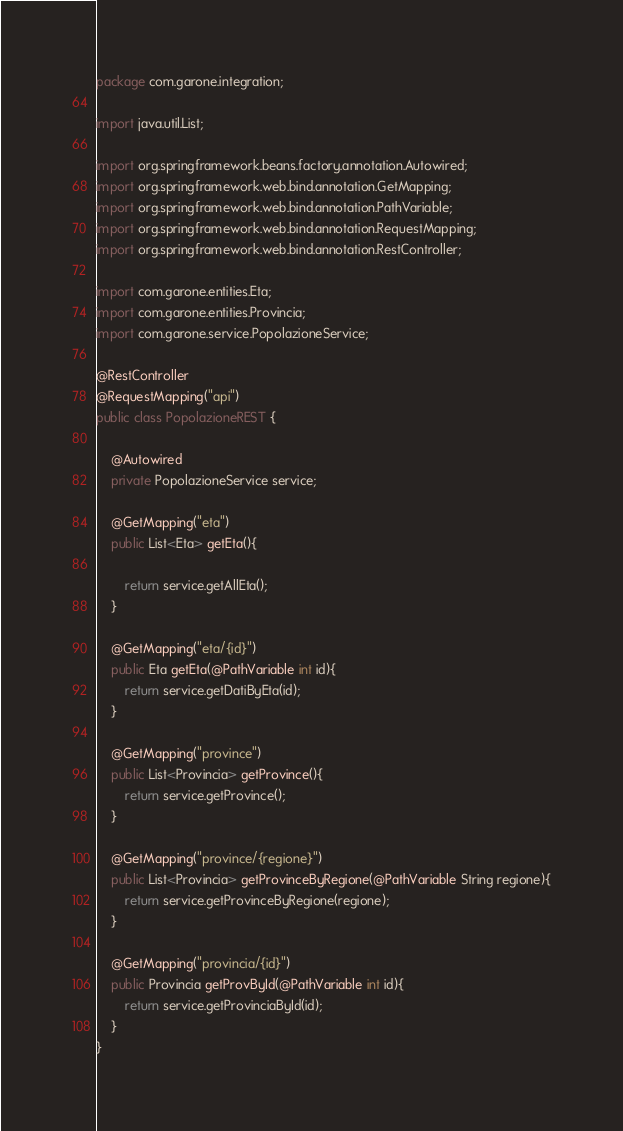<code> <loc_0><loc_0><loc_500><loc_500><_Java_>package com.garone.integration;

import java.util.List;

import org.springframework.beans.factory.annotation.Autowired;
import org.springframework.web.bind.annotation.GetMapping;
import org.springframework.web.bind.annotation.PathVariable;
import org.springframework.web.bind.annotation.RequestMapping;
import org.springframework.web.bind.annotation.RestController;

import com.garone.entities.Eta;
import com.garone.entities.Provincia;
import com.garone.service.PopolazioneService;

@RestController
@RequestMapping("api")
public class PopolazioneREST {

	@Autowired
	private PopolazioneService service;
	
	@GetMapping("eta")
	public List<Eta> getEta(){
		
		return service.getAllEta();
	}
	
	@GetMapping("eta/{id}")
	public Eta getEta(@PathVariable int id){
		return service.getDatiByEta(id);
	}
	
	@GetMapping("province")
	public List<Provincia> getProvince(){
		return service.getProvince();
	}	
	
	@GetMapping("province/{regione}")
	public List<Provincia> getProvinceByRegione(@PathVariable String regione){
		return service.getProvinceByRegione(regione);
	}
	
	@GetMapping("provincia/{id}")
	public Provincia getProvById(@PathVariable int id){
		return service.getProvinciaById(id);
	}
}
</code> 